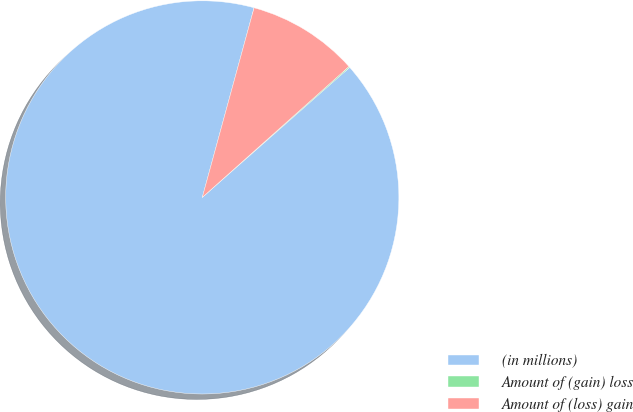Convert chart to OTSL. <chart><loc_0><loc_0><loc_500><loc_500><pie_chart><fcel>(in millions)<fcel>Amount of (gain) loss<fcel>Amount of (loss) gain<nl><fcel>90.75%<fcel>0.09%<fcel>9.16%<nl></chart> 